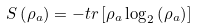<formula> <loc_0><loc_0><loc_500><loc_500>S \left ( \rho _ { a } \right ) = - t r \left [ \rho _ { a } \log _ { 2 } \left ( \rho _ { a } \right ) \right ]</formula> 